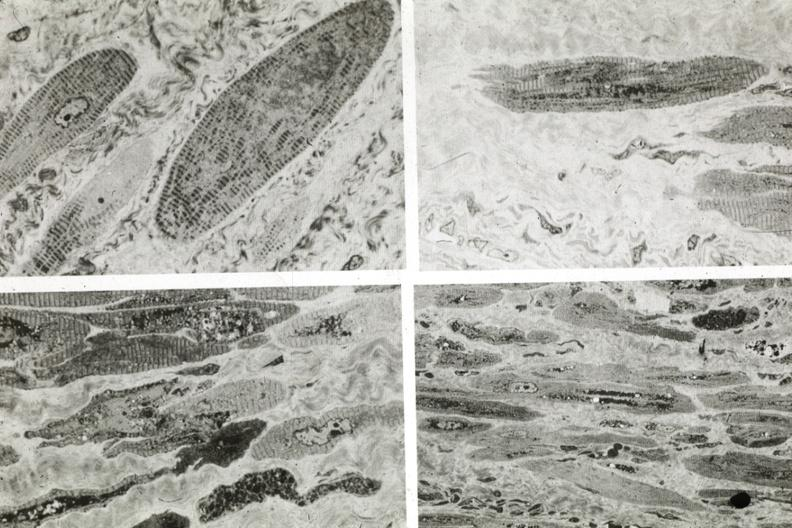does pus in test tube show marked fiber atrophy?
Answer the question using a single word or phrase. No 